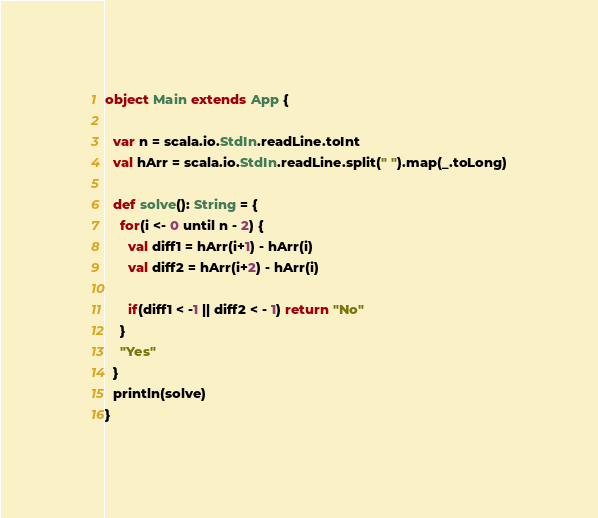Convert code to text. <code><loc_0><loc_0><loc_500><loc_500><_Scala_>


object Main extends App {

  var n = scala.io.StdIn.readLine.toInt
  val hArr = scala.io.StdIn.readLine.split(" ").map(_.toLong)

  def solve(): String = {
    for(i <- 0 until n - 2) {
      val diff1 = hArr(i+1) - hArr(i)
      val diff2 = hArr(i+2) - hArr(i)

      if(diff1 < -1 || diff2 < - 1) return "No"
    }
    "Yes"
  }
  println(solve)
}
</code> 